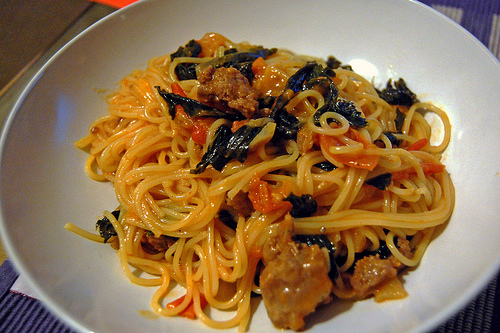<image>
Is there a noodles to the right of the plate? No. The noodles is not to the right of the plate. The horizontal positioning shows a different relationship. 